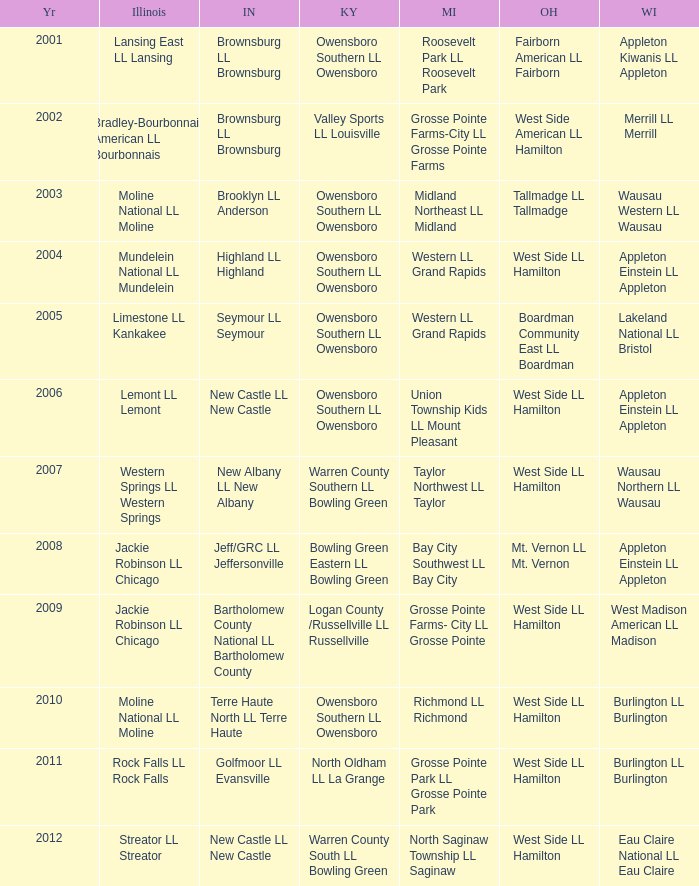Parse the table in full. {'header': ['Yr', 'Illinois', 'IN', 'KY', 'MI', 'OH', 'WI'], 'rows': [['2001', 'Lansing East LL Lansing', 'Brownsburg LL Brownsburg', 'Owensboro Southern LL Owensboro', 'Roosevelt Park LL Roosevelt Park', 'Fairborn American LL Fairborn', 'Appleton Kiwanis LL Appleton'], ['2002', 'Bradley-Bourbonnais American LL Bourbonnais', 'Brownsburg LL Brownsburg', 'Valley Sports LL Louisville', 'Grosse Pointe Farms-City LL Grosse Pointe Farms', 'West Side American LL Hamilton', 'Merrill LL Merrill'], ['2003', 'Moline National LL Moline', 'Brooklyn LL Anderson', 'Owensboro Southern LL Owensboro', 'Midland Northeast LL Midland', 'Tallmadge LL Tallmadge', 'Wausau Western LL Wausau'], ['2004', 'Mundelein National LL Mundelein', 'Highland LL Highland', 'Owensboro Southern LL Owensboro', 'Western LL Grand Rapids', 'West Side LL Hamilton', 'Appleton Einstein LL Appleton'], ['2005', 'Limestone LL Kankakee', 'Seymour LL Seymour', 'Owensboro Southern LL Owensboro', 'Western LL Grand Rapids', 'Boardman Community East LL Boardman', 'Lakeland National LL Bristol'], ['2006', 'Lemont LL Lemont', 'New Castle LL New Castle', 'Owensboro Southern LL Owensboro', 'Union Township Kids LL Mount Pleasant', 'West Side LL Hamilton', 'Appleton Einstein LL Appleton'], ['2007', 'Western Springs LL Western Springs', 'New Albany LL New Albany', 'Warren County Southern LL Bowling Green', 'Taylor Northwest LL Taylor', 'West Side LL Hamilton', 'Wausau Northern LL Wausau'], ['2008', 'Jackie Robinson LL Chicago', 'Jeff/GRC LL Jeffersonville', 'Bowling Green Eastern LL Bowling Green', 'Bay City Southwest LL Bay City', 'Mt. Vernon LL Mt. Vernon', 'Appleton Einstein LL Appleton'], ['2009', 'Jackie Robinson LL Chicago', 'Bartholomew County National LL Bartholomew County', 'Logan County /Russellville LL Russellville', 'Grosse Pointe Farms- City LL Grosse Pointe', 'West Side LL Hamilton', 'West Madison American LL Madison'], ['2010', 'Moline National LL Moline', 'Terre Haute North LL Terre Haute', 'Owensboro Southern LL Owensboro', 'Richmond LL Richmond', 'West Side LL Hamilton', 'Burlington LL Burlington'], ['2011', 'Rock Falls LL Rock Falls', 'Golfmoor LL Evansville', 'North Oldham LL La Grange', 'Grosse Pointe Park LL Grosse Pointe Park', 'West Side LL Hamilton', 'Burlington LL Burlington'], ['2012', 'Streator LL Streator', 'New Castle LL New Castle', 'Warren County South LL Bowling Green', 'North Saginaw Township LL Saginaw', 'West Side LL Hamilton', 'Eau Claire National LL Eau Claire']]} What was the little league team from Michigan when the little league team from Indiana was Terre Haute North LL Terre Haute?  Richmond LL Richmond. 